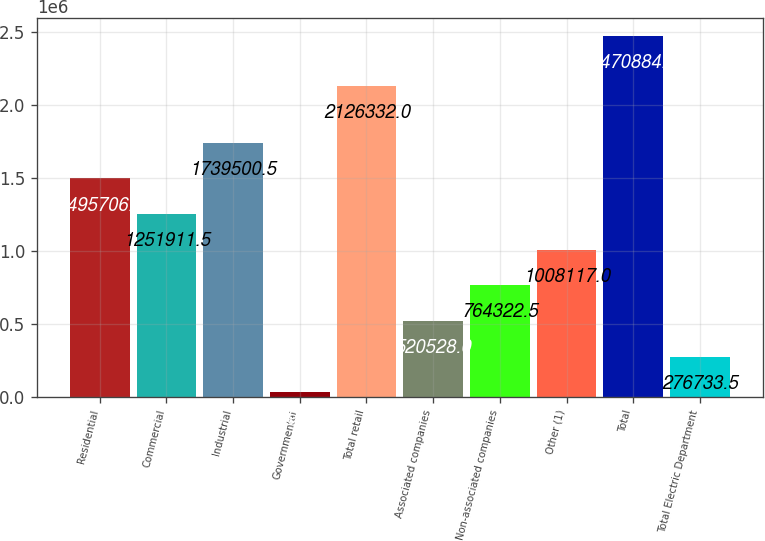<chart> <loc_0><loc_0><loc_500><loc_500><bar_chart><fcel>Residential<fcel>Commercial<fcel>Industrial<fcel>Governmental<fcel>Total retail<fcel>Associated companies<fcel>Non-associated companies<fcel>Other (1)<fcel>Total<fcel>Total Electric Department<nl><fcel>1.49571e+06<fcel>1.25191e+06<fcel>1.7395e+06<fcel>32939<fcel>2.12633e+06<fcel>520528<fcel>764322<fcel>1.00812e+06<fcel>2.47088e+06<fcel>276734<nl></chart> 